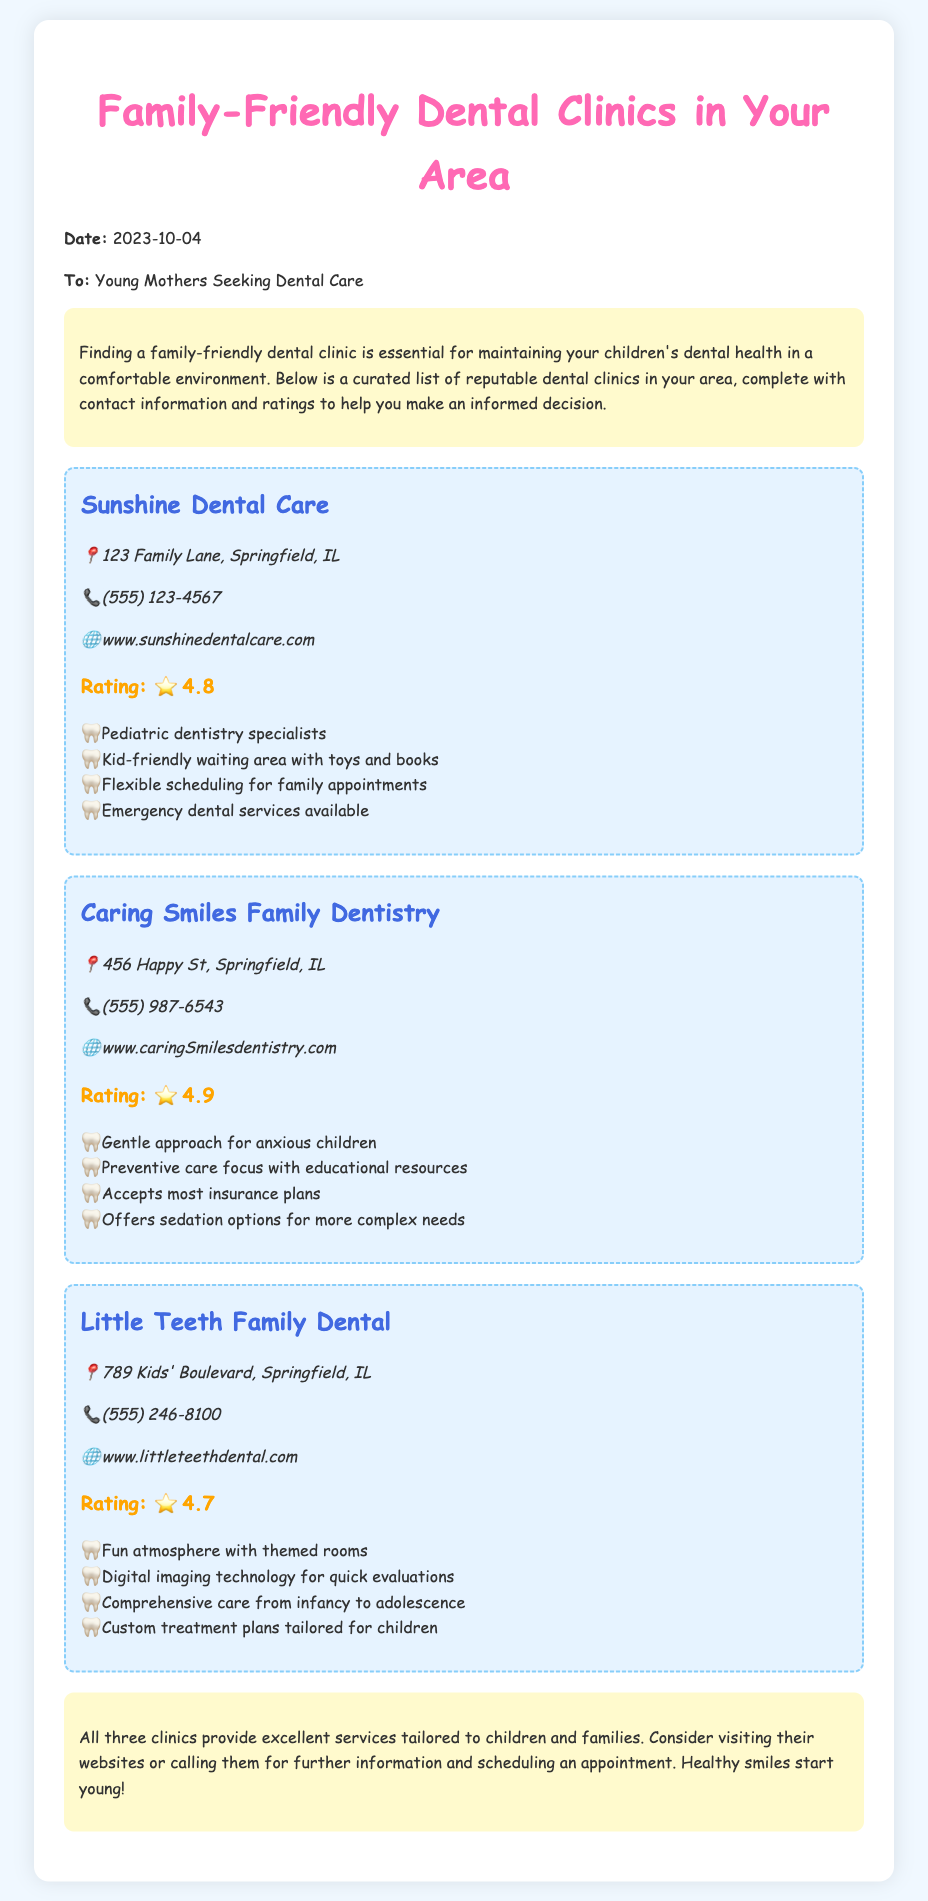What is the address of Sunshine Dental Care? The address is stated in the document under the clinic listing for Sunshine Dental Care.
Answer: 123 Family Lane, Springfield, IL What is the rating of Caring Smiles Family Dentistry? The rating is provided in the document within the respective clinic's section.
Answer: ⭐ 4.9 Which clinic offers emergency dental services? This information can be found in the features list for the clinic named Sunshine Dental Care.
Answer: Sunshine Dental Care How many clinics are listed in the document? The number of clinics can be counted based on the number of individual clinic sections presented in the memo.
Answer: 3 What is a feature of Little Teeth Family Dental? The document lists several features for this clinic, from which any one can be selected.
Answer: Fun atmosphere with themed rooms Which clinic has a website with "caringSmiles"? The document contains the website URL corresponding to the clinic named Caring Smiles Family Dentistry.
Answer: Caring Smiles Family Dentistry Does Little Teeth Family Dental provide services for infants? This information is directly referenced in the features section of the Little Teeth Family Dental.
Answer: Yes What type of document is this? The format and content suggest that this is an informational memo aimed at a specific audience.
Answer: Memo 